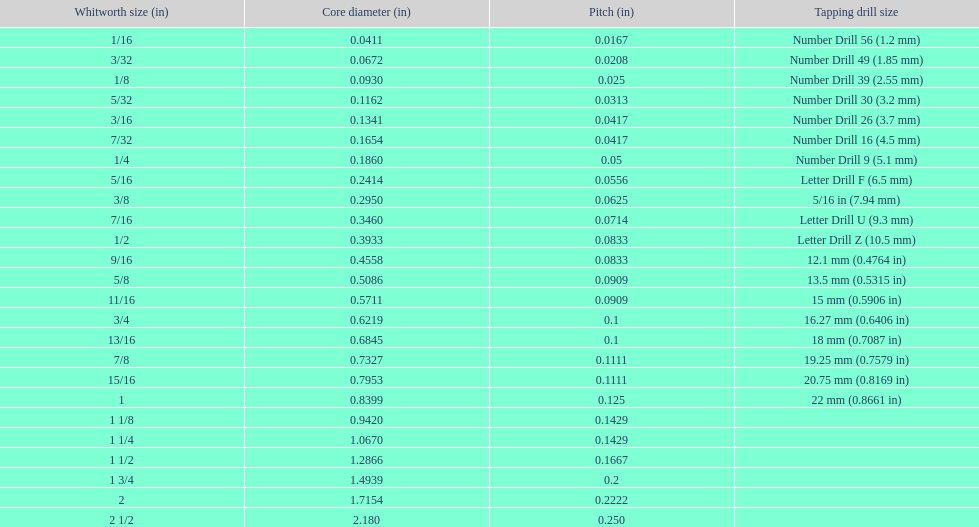Can you give me this table as a dict? {'header': ['Whitworth size (in)', 'Core diameter (in)', 'Pitch (in)', 'Tapping drill size'], 'rows': [['1/16', '0.0411', '0.0167', 'Number Drill 56 (1.2\xa0mm)'], ['3/32', '0.0672', '0.0208', 'Number Drill 49 (1.85\xa0mm)'], ['1/8', '0.0930', '0.025', 'Number Drill 39 (2.55\xa0mm)'], ['5/32', '0.1162', '0.0313', 'Number Drill 30 (3.2\xa0mm)'], ['3/16', '0.1341', '0.0417', 'Number Drill 26 (3.7\xa0mm)'], ['7/32', '0.1654', '0.0417', 'Number Drill 16 (4.5\xa0mm)'], ['1/4', '0.1860', '0.05', 'Number Drill 9 (5.1\xa0mm)'], ['5/16', '0.2414', '0.0556', 'Letter Drill F (6.5\xa0mm)'], ['3/8', '0.2950', '0.0625', '5/16\xa0in (7.94\xa0mm)'], ['7/16', '0.3460', '0.0714', 'Letter Drill U (9.3\xa0mm)'], ['1/2', '0.3933', '0.0833', 'Letter Drill Z (10.5\xa0mm)'], ['9/16', '0.4558', '0.0833', '12.1\xa0mm (0.4764\xa0in)'], ['5/8', '0.5086', '0.0909', '13.5\xa0mm (0.5315\xa0in)'], ['11/16', '0.5711', '0.0909', '15\xa0mm (0.5906\xa0in)'], ['3/4', '0.6219', '0.1', '16.27\xa0mm (0.6406\xa0in)'], ['13/16', '0.6845', '0.1', '18\xa0mm (0.7087\xa0in)'], ['7/8', '0.7327', '0.1111', '19.25\xa0mm (0.7579\xa0in)'], ['15/16', '0.7953', '0.1111', '20.75\xa0mm (0.8169\xa0in)'], ['1', '0.8399', '0.125', '22\xa0mm (0.8661\xa0in)'], ['1 1/8', '0.9420', '0.1429', ''], ['1 1/4', '1.0670', '0.1429', ''], ['1 1/2', '1.2866', '0.1667', ''], ['1 3/4', '1.4939', '0.2', ''], ['2', '1.7154', '0.2222', ''], ['2 1/2', '2.180', '0.250', '']]} Does any whitworth size have the same core diameter as the number drill 26? 3/16. 